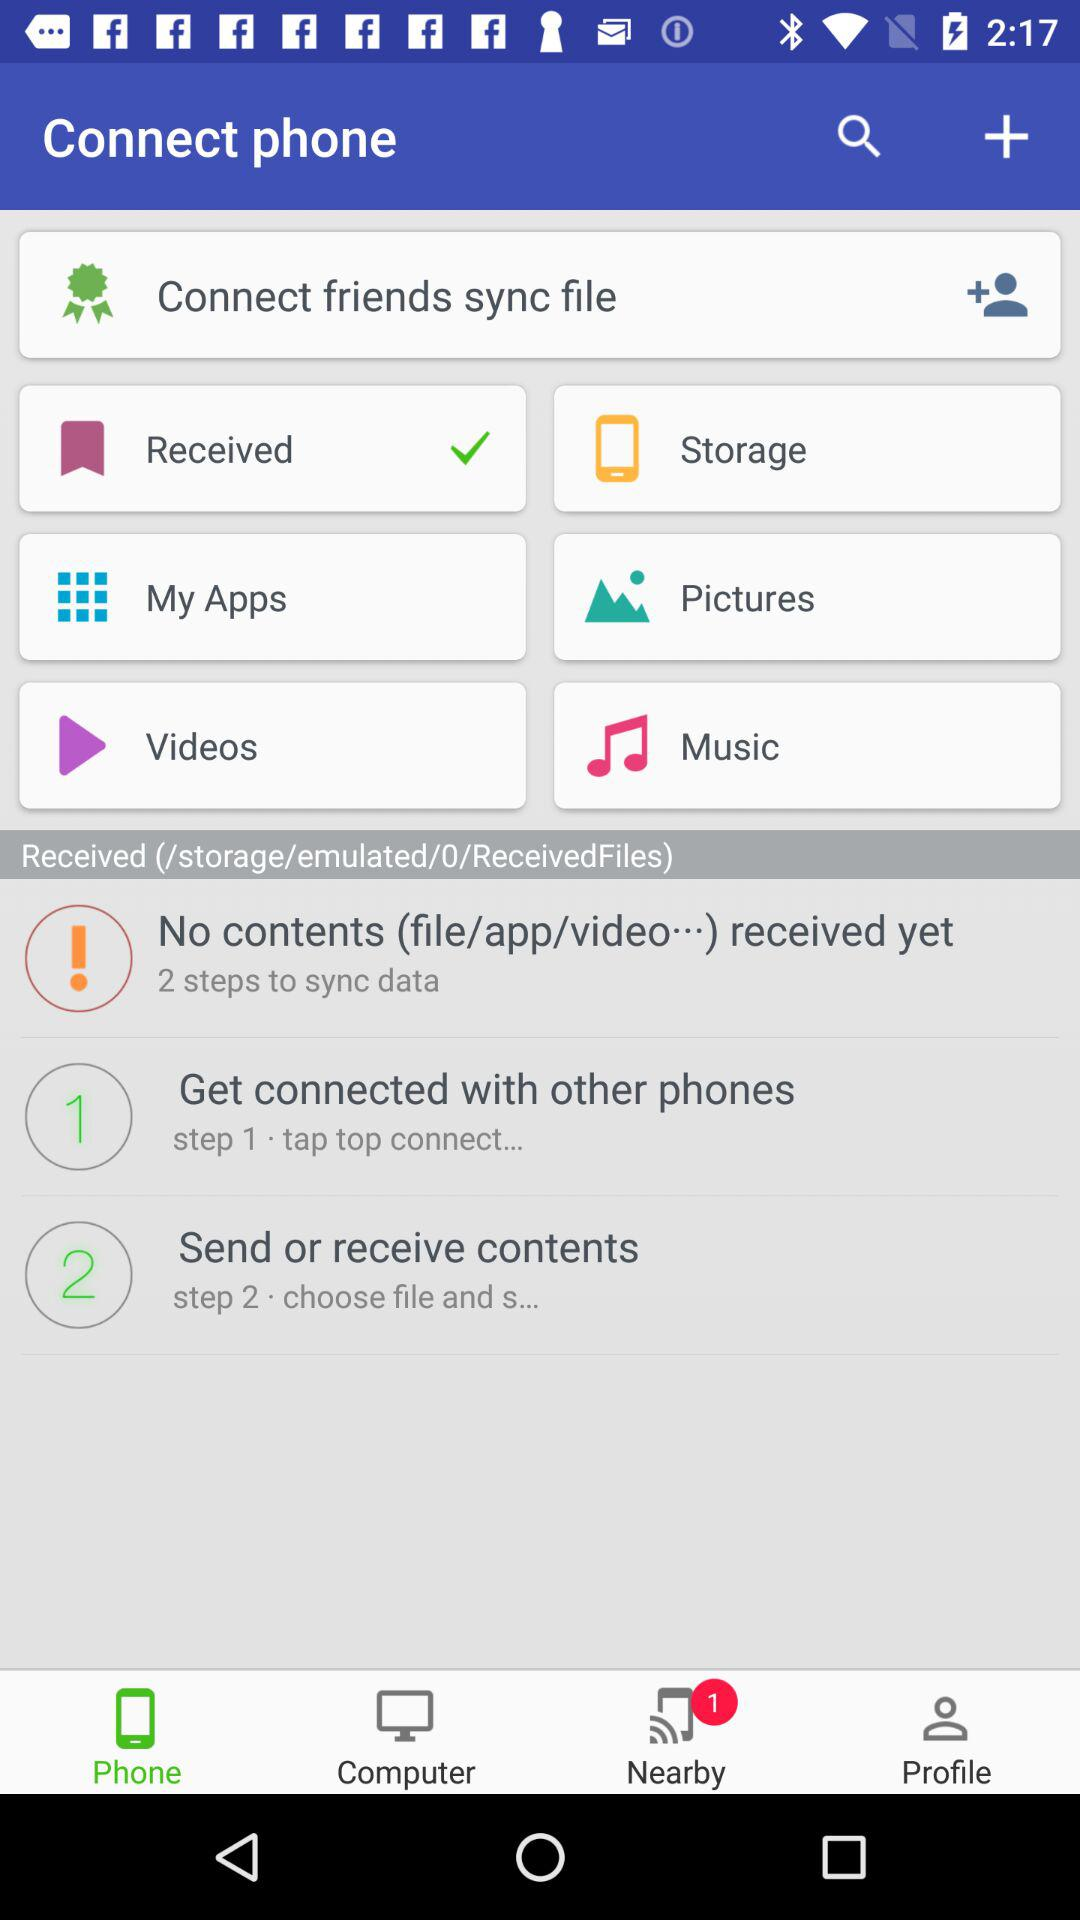How many steps are there to sync data?
Answer the question using a single word or phrase. 2 